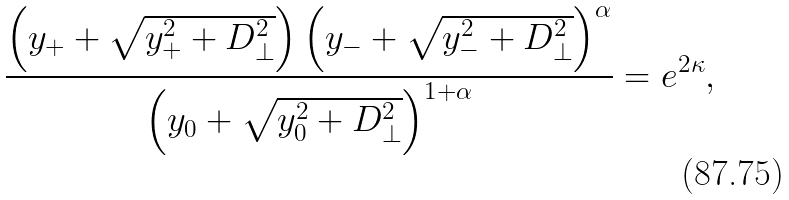<formula> <loc_0><loc_0><loc_500><loc_500>\frac { \left ( y _ { + } + \sqrt { y _ { + } ^ { 2 } + D _ { \perp } ^ { 2 } } \right ) \left ( y _ { - } + \sqrt { y _ { - } ^ { 2 } + D _ { \perp } ^ { 2 } } \right ) ^ { \alpha } } { \left ( y _ { 0 } + \sqrt { y _ { 0 } ^ { 2 } + D _ { \perp } ^ { 2 } } \right ) ^ { 1 + \alpha } } = e ^ { 2 \kappa } ,</formula> 